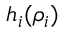<formula> <loc_0><loc_0><loc_500><loc_500>h _ { i } ( \rho _ { i } )</formula> 